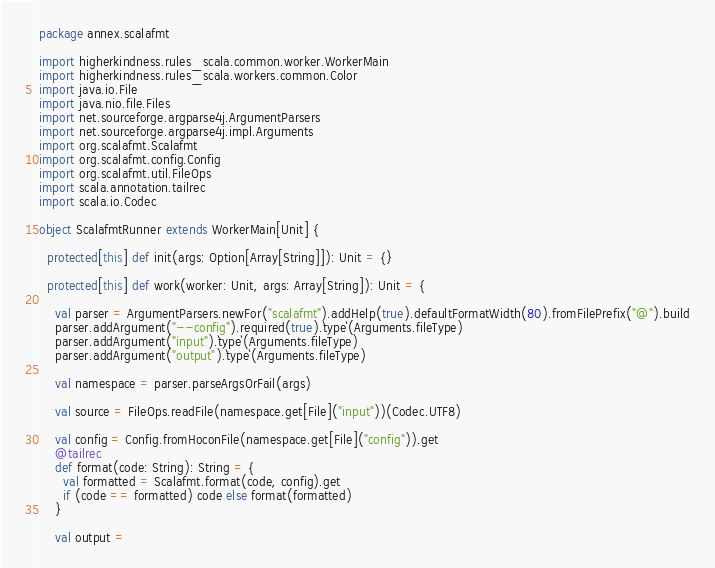<code> <loc_0><loc_0><loc_500><loc_500><_Scala_>package annex.scalafmt

import higherkindness.rules_scala.common.worker.WorkerMain
import higherkindness.rules_scala.workers.common.Color
import java.io.File
import java.nio.file.Files
import net.sourceforge.argparse4j.ArgumentParsers
import net.sourceforge.argparse4j.impl.Arguments
import org.scalafmt.Scalafmt
import org.scalafmt.config.Config
import org.scalafmt.util.FileOps
import scala.annotation.tailrec
import scala.io.Codec

object ScalafmtRunner extends WorkerMain[Unit] {

  protected[this] def init(args: Option[Array[String]]): Unit = {}

  protected[this] def work(worker: Unit, args: Array[String]): Unit = {

    val parser = ArgumentParsers.newFor("scalafmt").addHelp(true).defaultFormatWidth(80).fromFilePrefix("@").build
    parser.addArgument("--config").required(true).`type`(Arguments.fileType)
    parser.addArgument("input").`type`(Arguments.fileType)
    parser.addArgument("output").`type`(Arguments.fileType)

    val namespace = parser.parseArgsOrFail(args)

    val source = FileOps.readFile(namespace.get[File]("input"))(Codec.UTF8)

    val config = Config.fromHoconFile(namespace.get[File]("config")).get
    @tailrec
    def format(code: String): String = {
      val formatted = Scalafmt.format(code, config).get
      if (code == formatted) code else format(formatted)
    }

    val output =</code> 